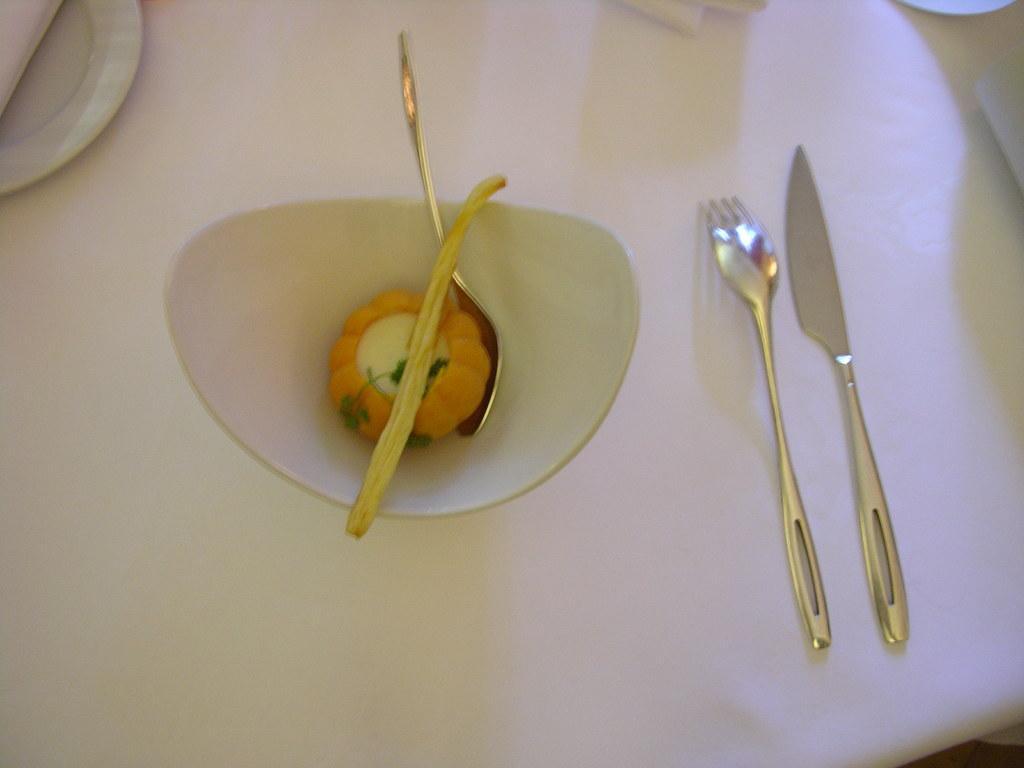How would you summarize this image in a sentence or two? In the picture we can see a table which is white in color and on it we can see a white color bowl with a sweet in it and a spoon and beside the bowl we can see a fork and a knife and near the bowl we can see a plate with some tissues in it. 